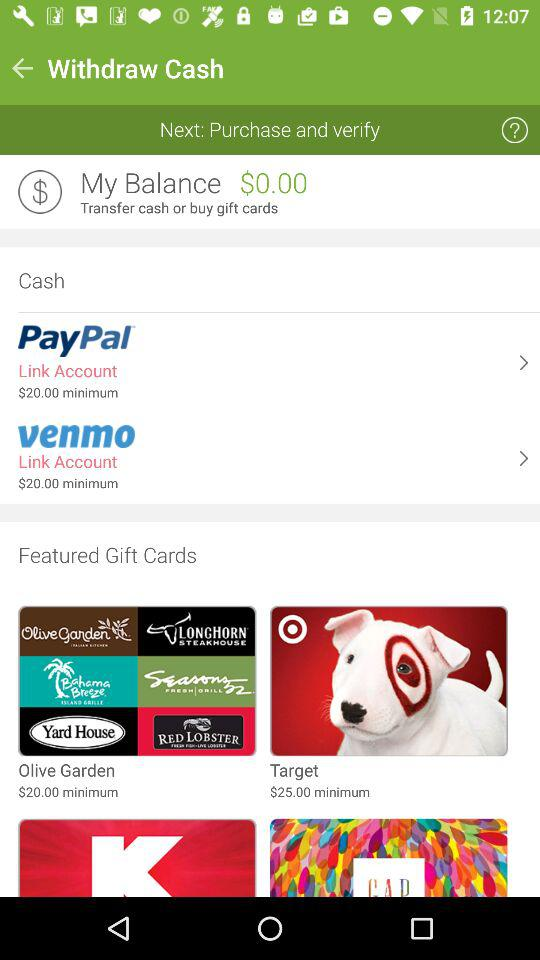How much is the minimum amount to transfer cash?
Answer the question using a single word or phrase. $20.00 